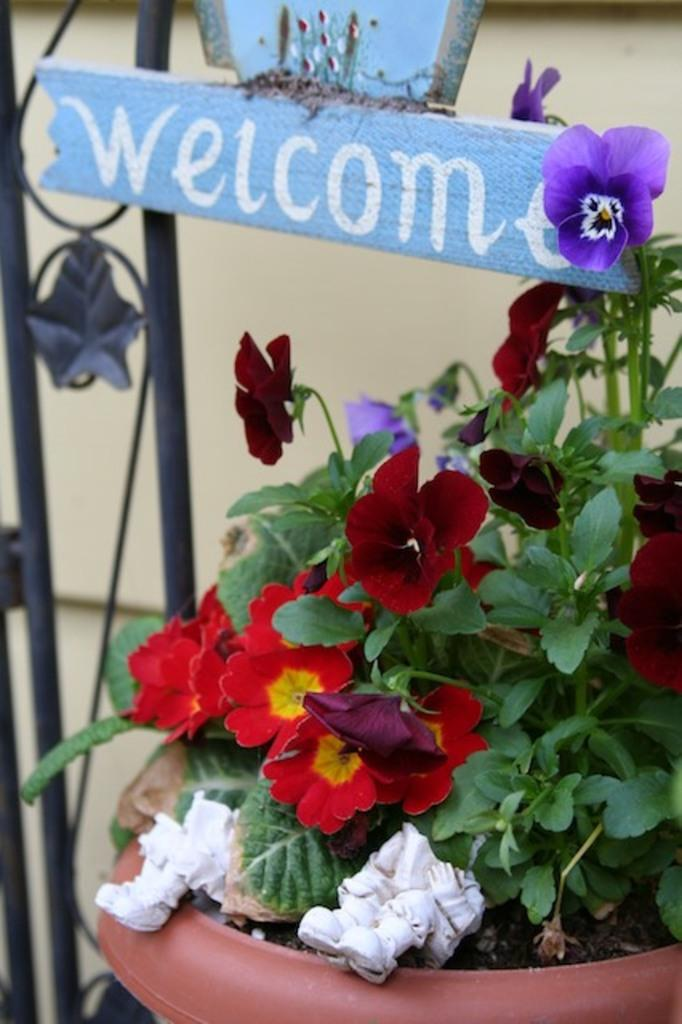What type of object is located in the left corner of the image? There is a metal object in the left corner of the image. What can be found in the right corner of the image? There is a potted plant with flowers and green leaves in the right corner of the image. What is written or displayed at the top of the image? There is a wooden board with text at the top of the image. What type of rub can be seen on the wooden board in the image? There is no rub visible on the wooden board in the image. What type of growth is depicted in the image? The image features a potted plant with flowers and green leaves, but there is no specific growth depicted beyond the plant itself. 